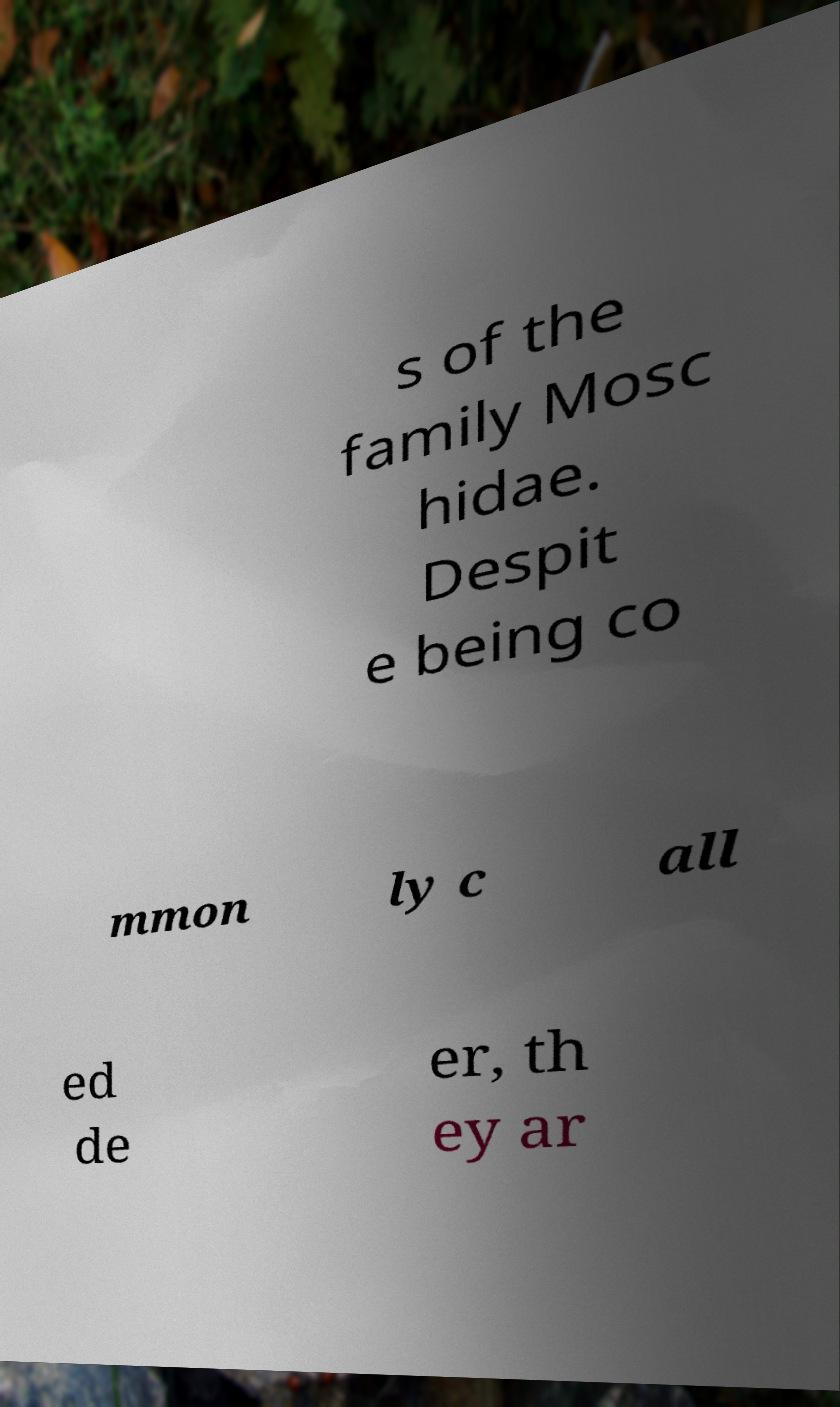Please read and relay the text visible in this image. What does it say? s of the family Mosc hidae. Despit e being co mmon ly c all ed de er, th ey ar 